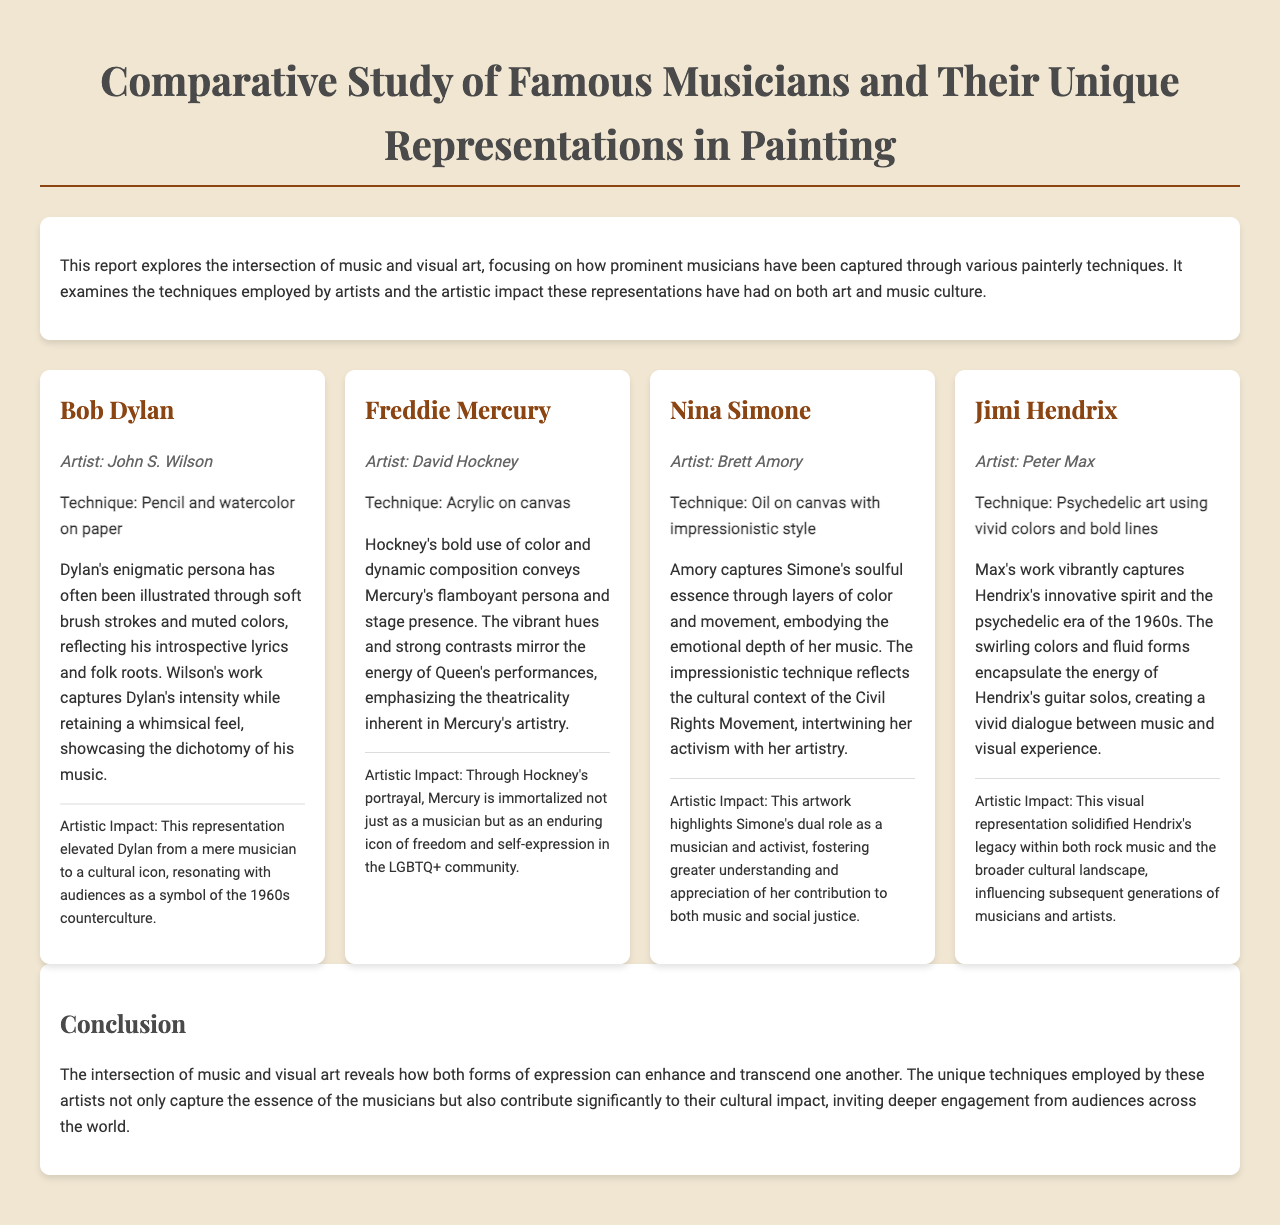What is the title of the report? The title is prominently displayed in the header section of the document.
Answer: Comparative Study of Famous Musicians and Their Unique Representations in Painting Who painted Bob Dylan? The document lists the artist associated with Bob Dylan's representation.
Answer: John S. Wilson What technique was used in Freddie Mercury's painting? The document specifies the artistic techniques used for each musician's portrayal.
Answer: Acrylic on canvas Which musician is associated with the technique of oil on canvas? The document provides information about the techniques corresponding to each musician.
Answer: Nina Simone What artistic impact is attributed to Jimi Hendrix's representation? The impact is described in relation to how Hendrix's visual representation influenced cultural perceptions.
Answer: Influencing subsequent generations of musicians and artists Which artist utilized psychedelic art techniques for Hendrix? The document directly identifies the artist who created Hendrix's representation.
Answer: Peter Max How many musicians are discussed in the document? The document lists each musician and their representation, allowing for a count.
Answer: Four What style of painting is associated with Nina Simone? The painting style is described in the context of her representation.
Answer: Impressionistic style What summary theme is presented in the conclusion? The conclusion encapsulates the thematic essence of the relationship between music and visual art.
Answer: Intersection of music and visual art 